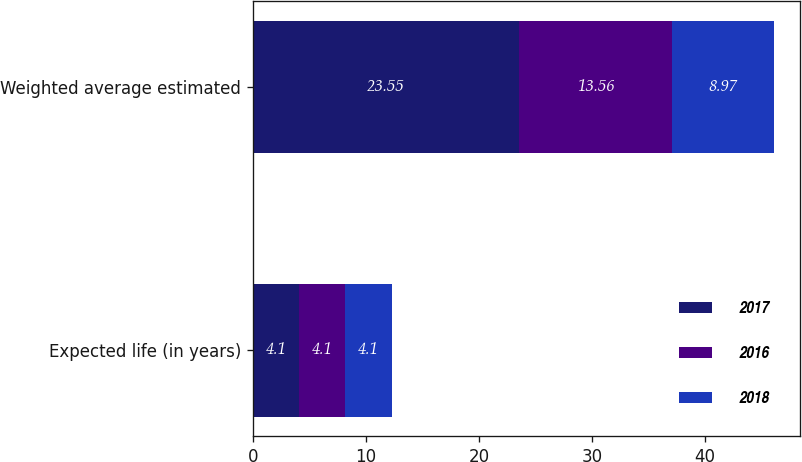Convert chart. <chart><loc_0><loc_0><loc_500><loc_500><stacked_bar_chart><ecel><fcel>Expected life (in years)<fcel>Weighted average estimated<nl><fcel>2017<fcel>4.1<fcel>23.55<nl><fcel>2016<fcel>4.1<fcel>13.56<nl><fcel>2018<fcel>4.1<fcel>8.97<nl></chart> 